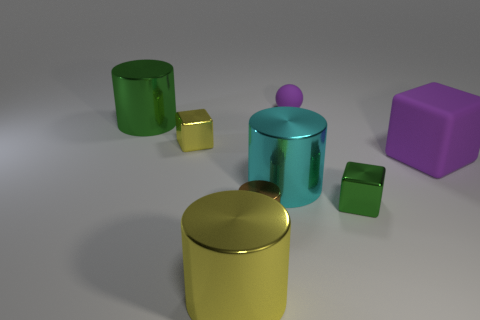What size is the ball that is the same color as the large matte thing?
Offer a terse response. Small. Is the tiny ball the same color as the rubber block?
Offer a very short reply. Yes. What is the shape of the small thing that is both behind the purple matte cube and left of the big cyan object?
Your answer should be very brief. Cube. There is a rubber thing to the left of the purple matte cube; does it have the same color as the matte block?
Your response must be concise. Yes. There is a small thing on the right side of the ball; is its shape the same as the metallic object that is in front of the brown object?
Provide a short and direct response. No. There is a green object that is right of the small purple sphere; what is its size?
Give a very brief answer. Small. There is a green thing that is on the right side of the large object that is behind the yellow metallic block; what size is it?
Your response must be concise. Small. Is the number of large green cylinders greater than the number of big cyan rubber objects?
Offer a very short reply. Yes. Are there more big cyan objects that are behind the large matte object than large matte things that are right of the tiny brown thing?
Your answer should be very brief. No. What size is the thing that is behind the small yellow cube and in front of the purple sphere?
Your answer should be compact. Large. 